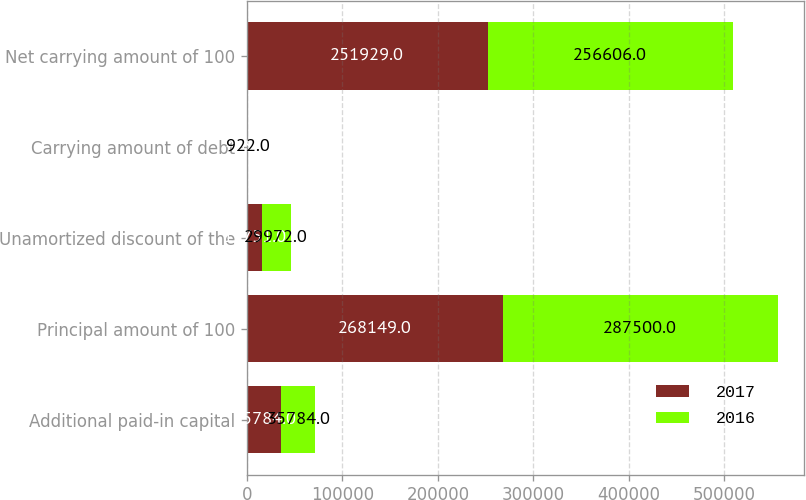Convert chart. <chart><loc_0><loc_0><loc_500><loc_500><stacked_bar_chart><ecel><fcel>Additional paid-in capital<fcel>Principal amount of 100<fcel>Unamortized discount of the<fcel>Carrying amount of debt<fcel>Net carrying amount of 100<nl><fcel>2017<fcel>35784<fcel>268149<fcel>15751<fcel>469<fcel>251929<nl><fcel>2016<fcel>35784<fcel>287500<fcel>29972<fcel>922<fcel>256606<nl></chart> 